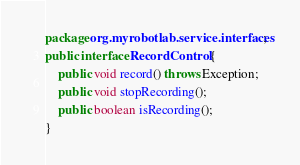Convert code to text. <code><loc_0><loc_0><loc_500><loc_500><_Java_>package org.myrobotlab.service.interfaces;

public interface RecordControl {
	
	public void record() throws Exception;
	
	public void stopRecording();
	
	public boolean isRecording();

}
</code> 